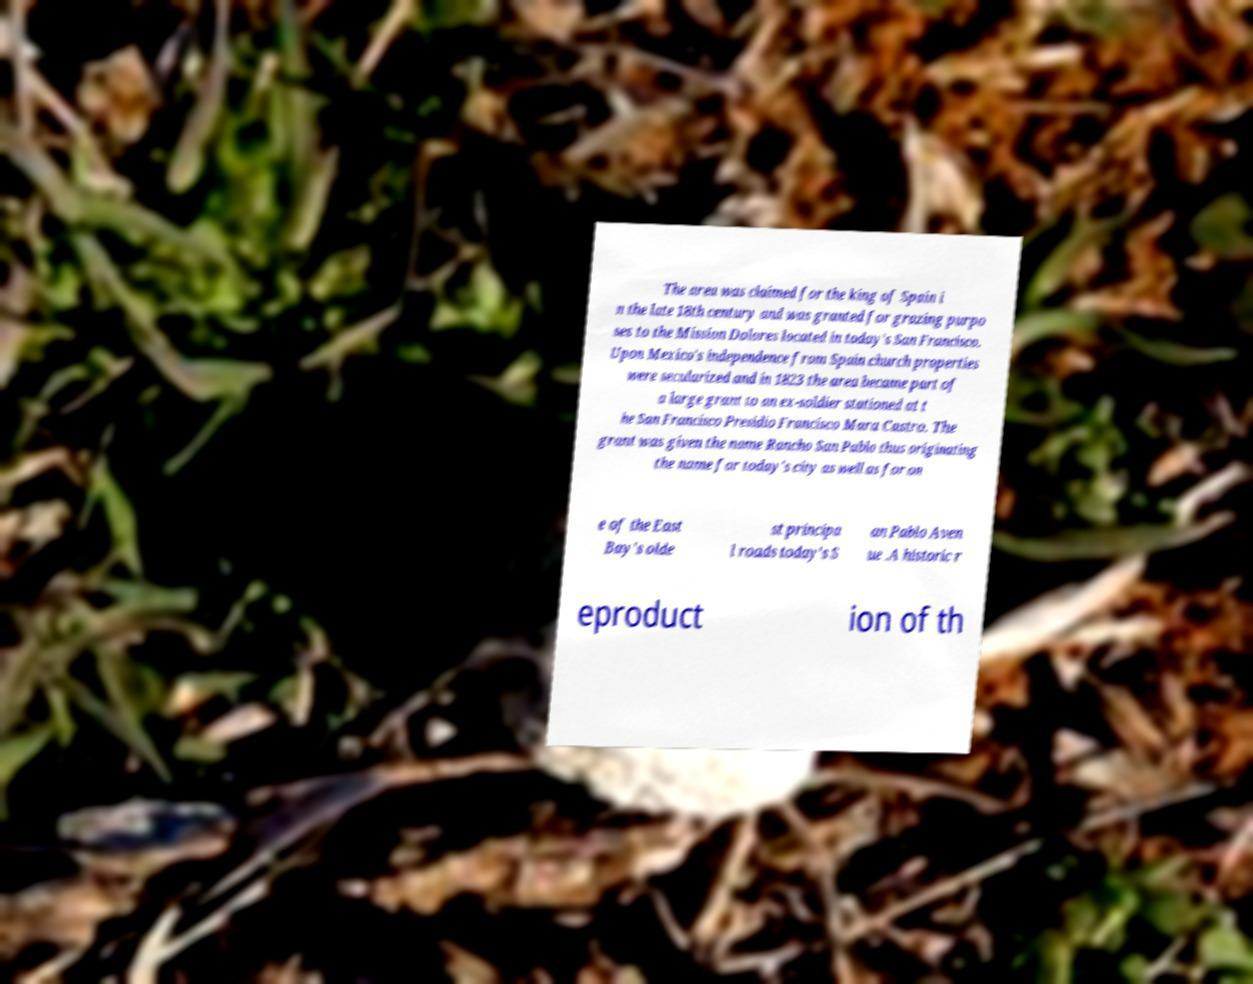Can you read and provide the text displayed in the image?This photo seems to have some interesting text. Can you extract and type it out for me? The area was claimed for the king of Spain i n the late 18th century and was granted for grazing purpo ses to the Mission Dolores located in today's San Francisco. Upon Mexico's independence from Spain church properties were secularized and in 1823 the area became part of a large grant to an ex-soldier stationed at t he San Francisco Presidio Francisco Mara Castro. The grant was given the name Rancho San Pablo thus originating the name for today's city as well as for on e of the East Bay's olde st principa l roads today's S an Pablo Aven ue .A historic r eproduct ion of th 